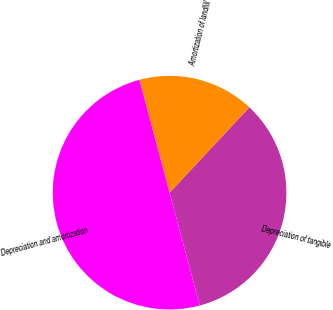Convert chart. <chart><loc_0><loc_0><loc_500><loc_500><pie_chart><fcel>Depreciation of tangible<fcel>Amortization of landfill<fcel>Depreciation and amortization<nl><fcel>33.87%<fcel>16.13%<fcel>50.0%<nl></chart> 